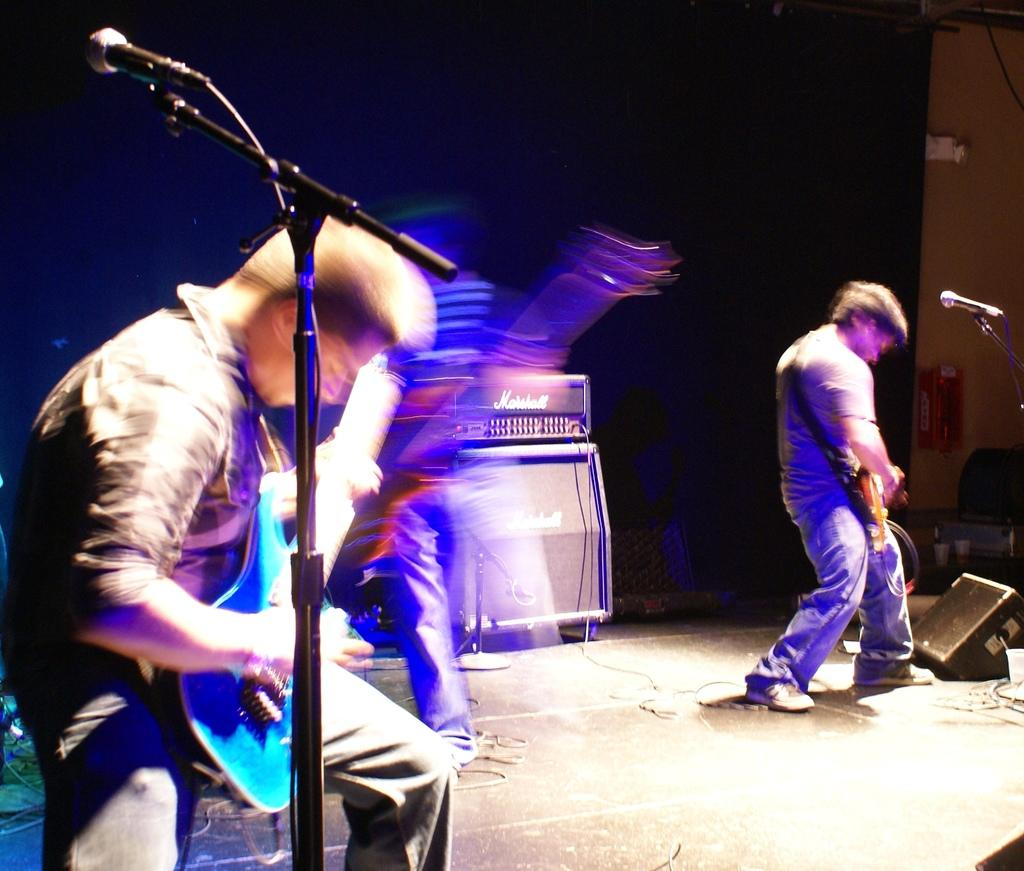Who or what is present in the image? There are people in the image. What are the people holding in the image? The people are holding guitars. What equipment can be seen in the image related to sound? There are microphones and speakers in the image. Can you describe the background of the image? There is a black-colored object in the background of the image. What type of rail can be seen in the image? There is no rail present in the image. What book is the person reading in the image? There is no person reading a book in the image; the people are holding guitars. 